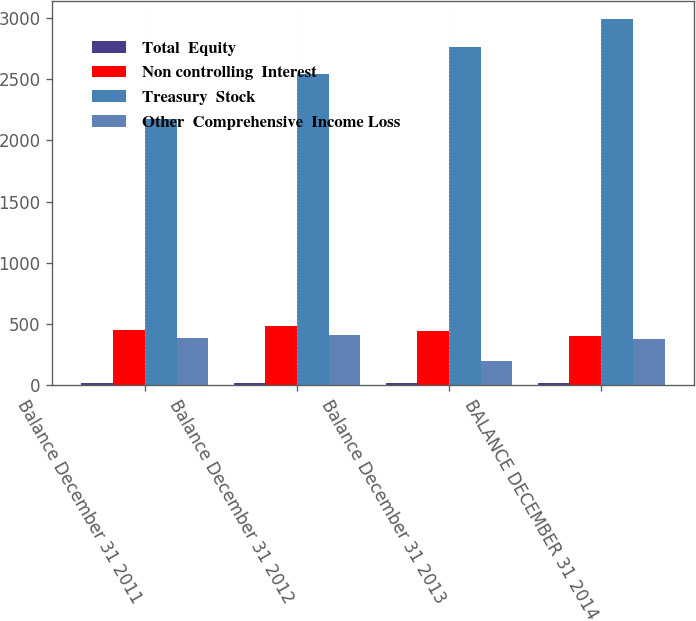<chart> <loc_0><loc_0><loc_500><loc_500><stacked_bar_chart><ecel><fcel>Balance December 31 2011<fcel>Balance December 31 2012<fcel>Balance December 31 2013<fcel>BALANCE DECEMBER 31 2014<nl><fcel>Total  Equity<fcel>18.6<fcel>18.6<fcel>18.6<fcel>18.6<nl><fcel>Non controlling  Interest<fcel>454.5<fcel>481.9<fcel>448.3<fcel>401.9<nl><fcel>Treasury  Stock<fcel>2176.2<fcel>2536.5<fcel>2757.3<fcel>2984.5<nl><fcel>Other  Comprehensive  Income Loss<fcel>390<fcel>408.9<fcel>201.9<fcel>375.8<nl></chart> 